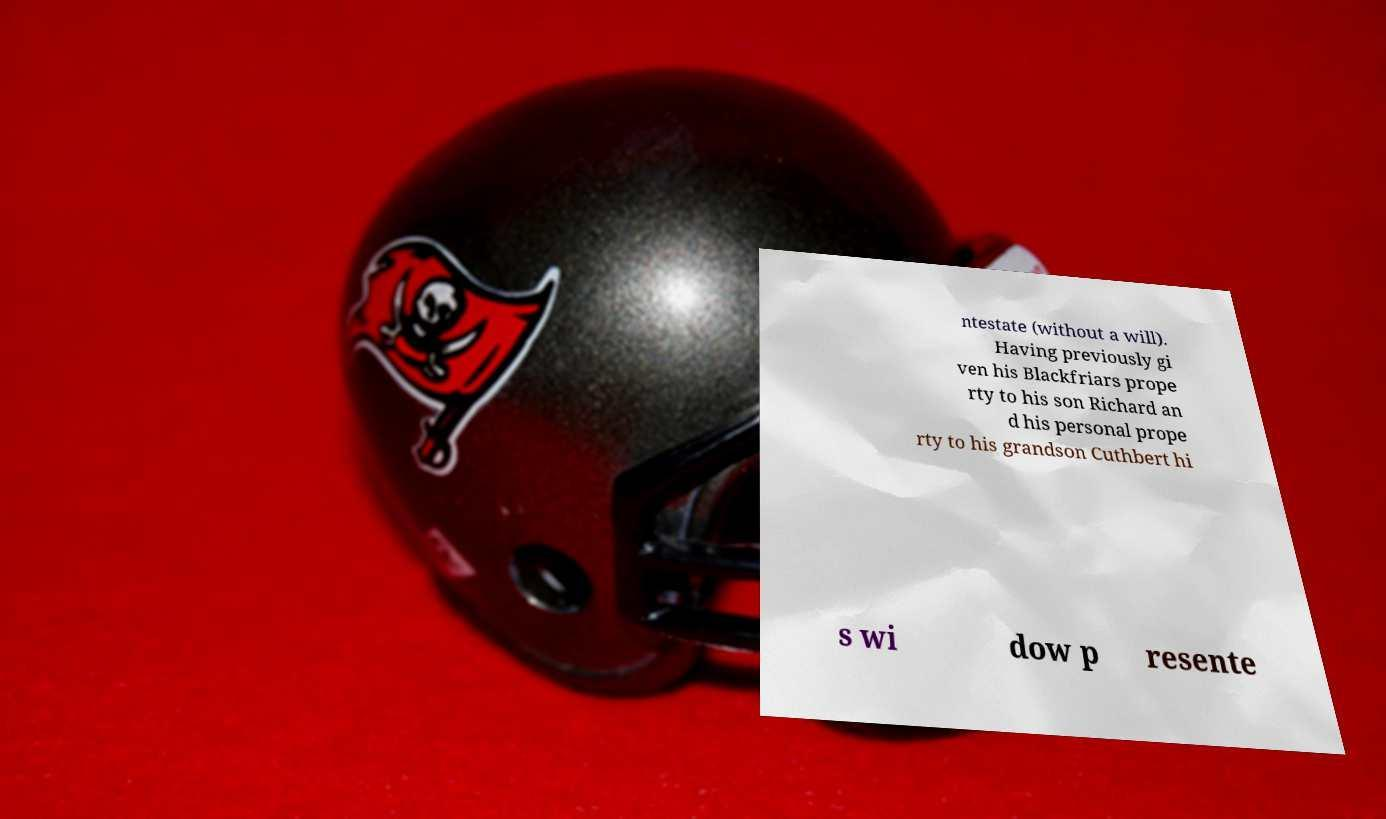Please identify and transcribe the text found in this image. ntestate (without a will). Having previously gi ven his Blackfriars prope rty to his son Richard an d his personal prope rty to his grandson Cuthbert hi s wi dow p resente 